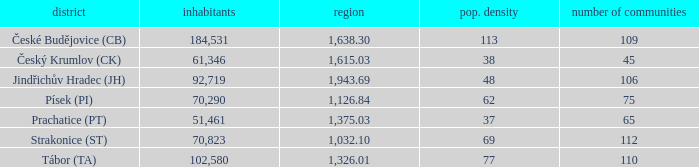What is the lowest population density of Strakonice (st) with more than 112 settlements? None. 